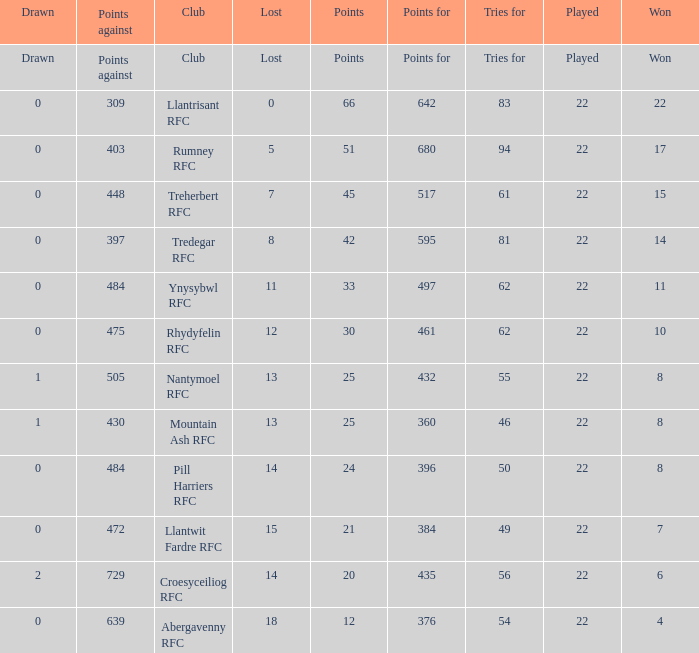Which club lost exactly 7 matches? Treherbert RFC. 